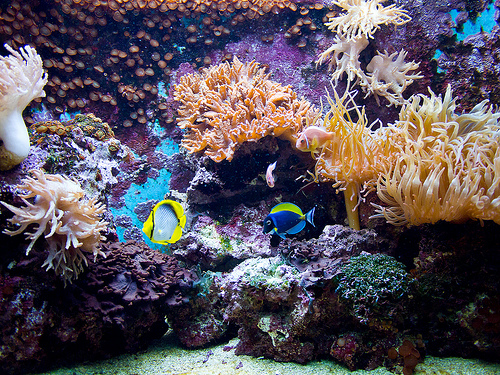<image>
Is the fish on the coral? No. The fish is not positioned on the coral. They may be near each other, but the fish is not supported by or resting on top of the coral. 